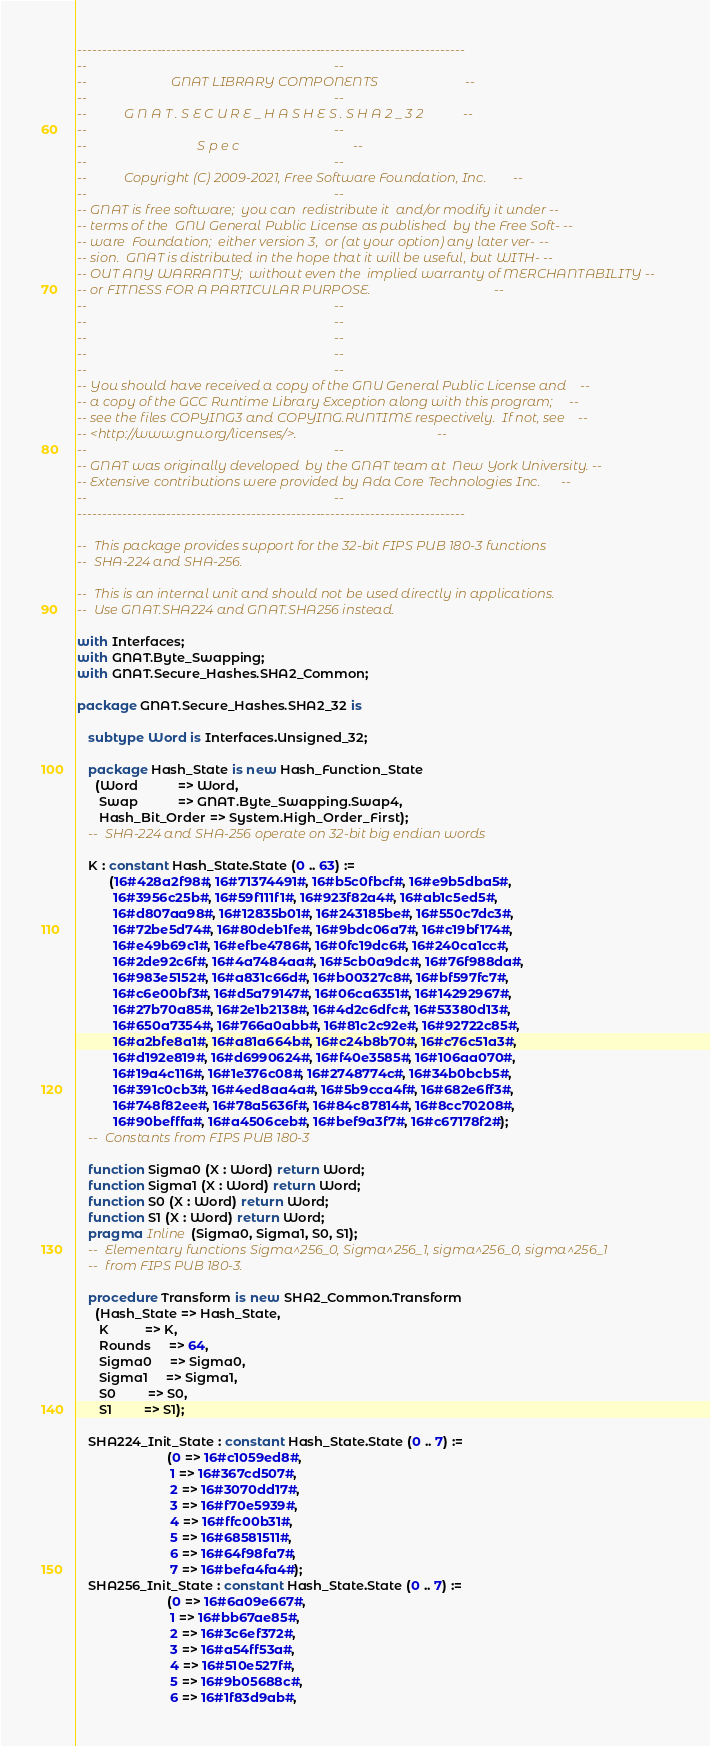Convert code to text. <code><loc_0><loc_0><loc_500><loc_500><_Ada_>------------------------------------------------------------------------------
--                                                                          --
--                         GNAT LIBRARY COMPONENTS                          --
--                                                                          --
--           G N A T . S E C U R E _ H A S H E S . S H A 2 _ 3 2            --
--                                                                          --
--                                 S p e c                                  --
--                                                                          --
--           Copyright (C) 2009-2021, Free Software Foundation, Inc.        --
--                                                                          --
-- GNAT is free software;  you can  redistribute it  and/or modify it under --
-- terms of the  GNU General Public License as published  by the Free Soft- --
-- ware  Foundation;  either version 3,  or (at your option) any later ver- --
-- sion.  GNAT is distributed in the hope that it will be useful, but WITH- --
-- OUT ANY WARRANTY;  without even the  implied warranty of MERCHANTABILITY --
-- or FITNESS FOR A PARTICULAR PURPOSE.                                     --
--                                                                          --
--                                                                          --
--                                                                          --
--                                                                          --
--                                                                          --
-- You should have received a copy of the GNU General Public License and    --
-- a copy of the GCC Runtime Library Exception along with this program;     --
-- see the files COPYING3 and COPYING.RUNTIME respectively.  If not, see    --
-- <http://www.gnu.org/licenses/>.                                          --
--                                                                          --
-- GNAT was originally developed  by the GNAT team at  New York University. --
-- Extensive contributions were provided by Ada Core Technologies Inc.      --
--                                                                          --
------------------------------------------------------------------------------

--  This package provides support for the 32-bit FIPS PUB 180-3 functions
--  SHA-224 and SHA-256.

--  This is an internal unit and should not be used directly in applications.
--  Use GNAT.SHA224 and GNAT.SHA256 instead.

with Interfaces;
with GNAT.Byte_Swapping;
with GNAT.Secure_Hashes.SHA2_Common;

package GNAT.Secure_Hashes.SHA2_32 is

   subtype Word is Interfaces.Unsigned_32;

   package Hash_State is new Hash_Function_State
     (Word           => Word,
      Swap           => GNAT.Byte_Swapping.Swap4,
      Hash_Bit_Order => System.High_Order_First);
   --  SHA-224 and SHA-256 operate on 32-bit big endian words

   K : constant Hash_State.State (0 .. 63) :=
         (16#428a2f98#, 16#71374491#, 16#b5c0fbcf#, 16#e9b5dba5#,
          16#3956c25b#, 16#59f111f1#, 16#923f82a4#, 16#ab1c5ed5#,
          16#d807aa98#, 16#12835b01#, 16#243185be#, 16#550c7dc3#,
          16#72be5d74#, 16#80deb1fe#, 16#9bdc06a7#, 16#c19bf174#,
          16#e49b69c1#, 16#efbe4786#, 16#0fc19dc6#, 16#240ca1cc#,
          16#2de92c6f#, 16#4a7484aa#, 16#5cb0a9dc#, 16#76f988da#,
          16#983e5152#, 16#a831c66d#, 16#b00327c8#, 16#bf597fc7#,
          16#c6e00bf3#, 16#d5a79147#, 16#06ca6351#, 16#14292967#,
          16#27b70a85#, 16#2e1b2138#, 16#4d2c6dfc#, 16#53380d13#,
          16#650a7354#, 16#766a0abb#, 16#81c2c92e#, 16#92722c85#,
          16#a2bfe8a1#, 16#a81a664b#, 16#c24b8b70#, 16#c76c51a3#,
          16#d192e819#, 16#d6990624#, 16#f40e3585#, 16#106aa070#,
          16#19a4c116#, 16#1e376c08#, 16#2748774c#, 16#34b0bcb5#,
          16#391c0cb3#, 16#4ed8aa4a#, 16#5b9cca4f#, 16#682e6ff3#,
          16#748f82ee#, 16#78a5636f#, 16#84c87814#, 16#8cc70208#,
          16#90befffa#, 16#a4506ceb#, 16#bef9a3f7#, 16#c67178f2#);
   --  Constants from FIPS PUB 180-3

   function Sigma0 (X : Word) return Word;
   function Sigma1 (X : Word) return Word;
   function S0 (X : Word) return Word;
   function S1 (X : Word) return Word;
   pragma Inline (Sigma0, Sigma1, S0, S1);
   --  Elementary functions Sigma^256_0, Sigma^256_1, sigma^256_0, sigma^256_1
   --  from FIPS PUB 180-3.

   procedure Transform is new SHA2_Common.Transform
     (Hash_State => Hash_State,
      K          => K,
      Rounds     => 64,
      Sigma0     => Sigma0,
      Sigma1     => Sigma1,
      S0         => S0,
      S1         => S1);

   SHA224_Init_State : constant Hash_State.State (0 .. 7) :=
                         (0 => 16#c1059ed8#,
                          1 => 16#367cd507#,
                          2 => 16#3070dd17#,
                          3 => 16#f70e5939#,
                          4 => 16#ffc00b31#,
                          5 => 16#68581511#,
                          6 => 16#64f98fa7#,
                          7 => 16#befa4fa4#);
   SHA256_Init_State : constant Hash_State.State (0 .. 7) :=
                         (0 => 16#6a09e667#,
                          1 => 16#bb67ae85#,
                          2 => 16#3c6ef372#,
                          3 => 16#a54ff53a#,
                          4 => 16#510e527f#,
                          5 => 16#9b05688c#,
                          6 => 16#1f83d9ab#,</code> 